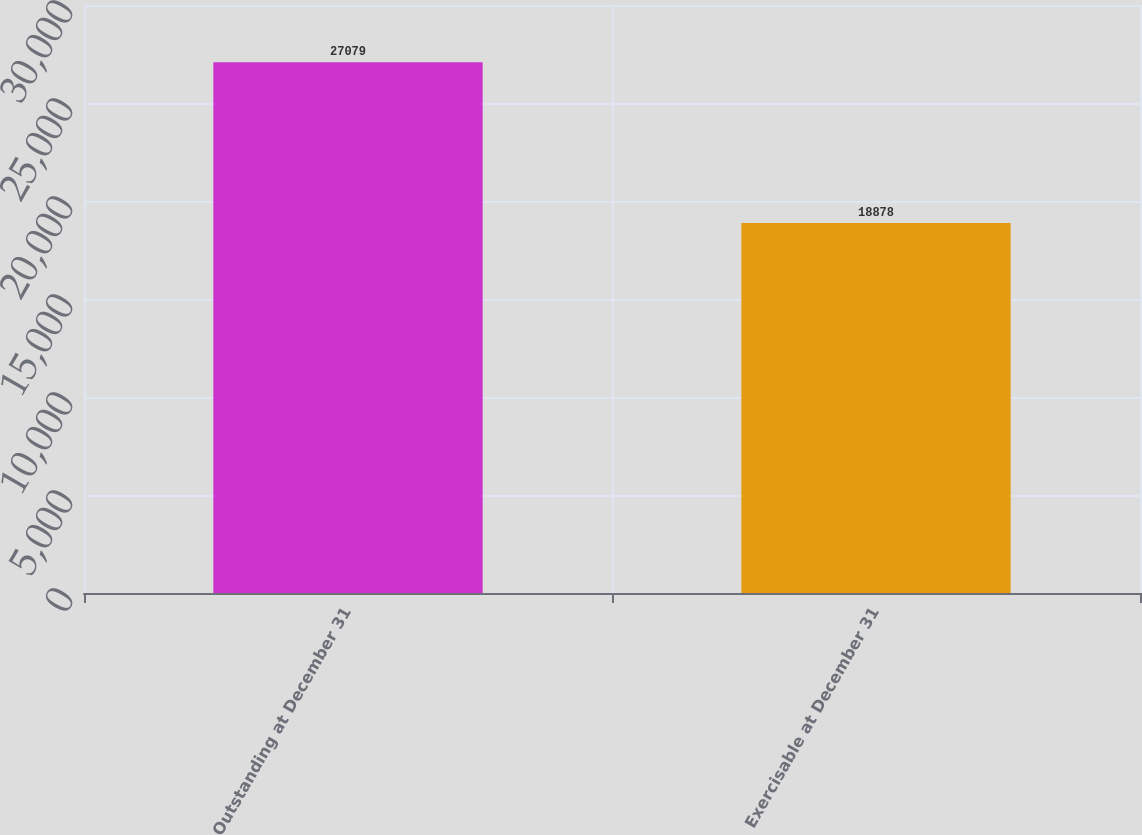Convert chart to OTSL. <chart><loc_0><loc_0><loc_500><loc_500><bar_chart><fcel>Outstanding at December 31<fcel>Exercisable at December 31<nl><fcel>27079<fcel>18878<nl></chart> 